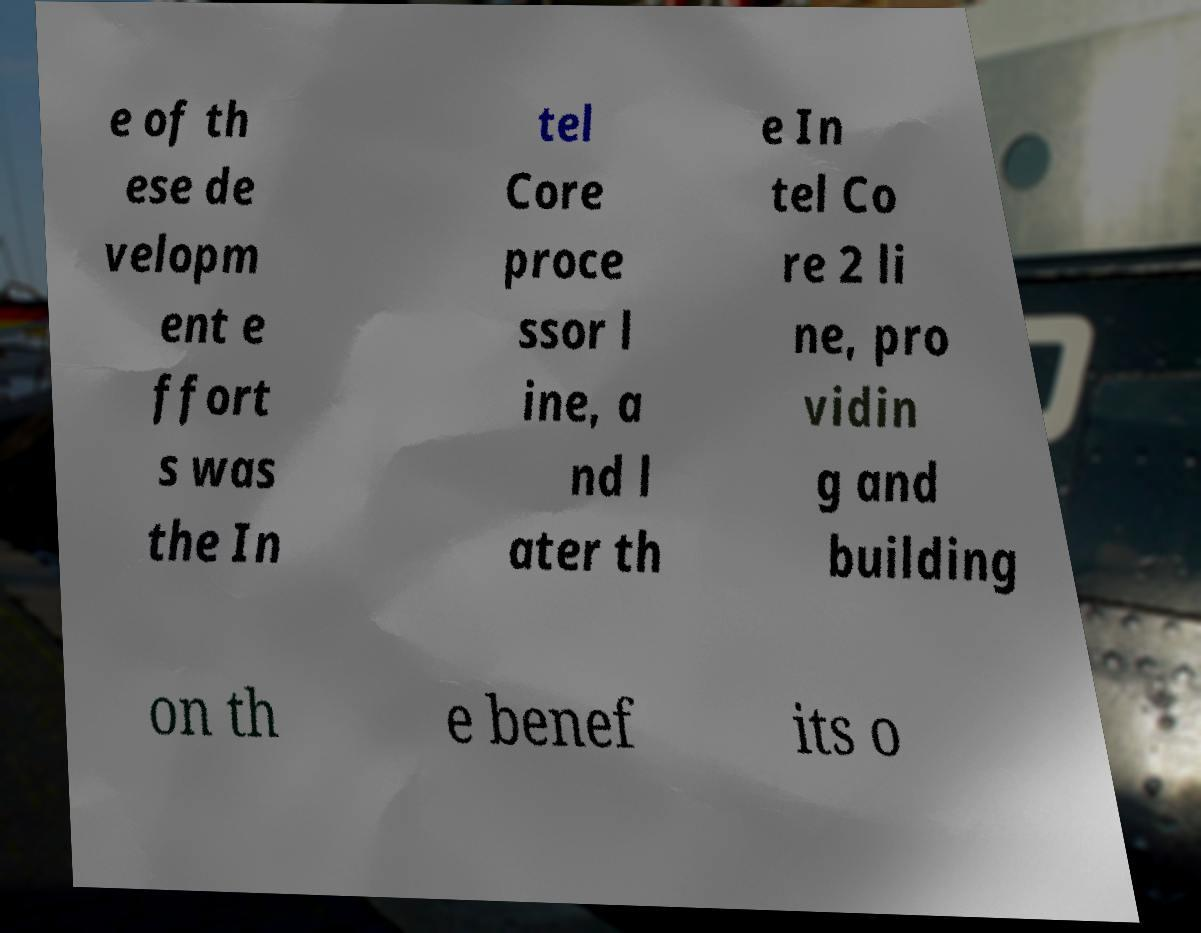Can you read and provide the text displayed in the image?This photo seems to have some interesting text. Can you extract and type it out for me? e of th ese de velopm ent e ffort s was the In tel Core proce ssor l ine, a nd l ater th e In tel Co re 2 li ne, pro vidin g and building on th e benef its o 